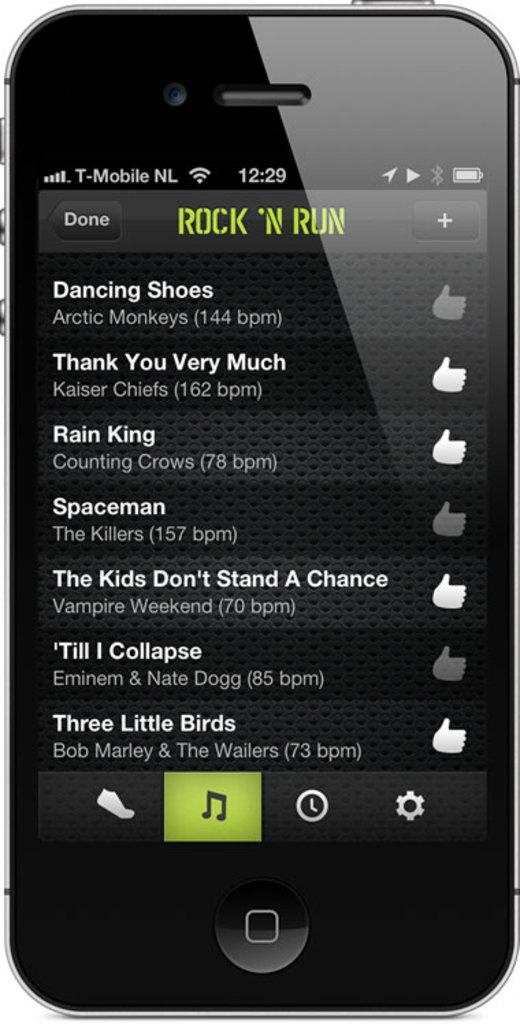Provide a one-sentence caption for the provided image. The front of a cell phone listing songs like Three little Birds. 